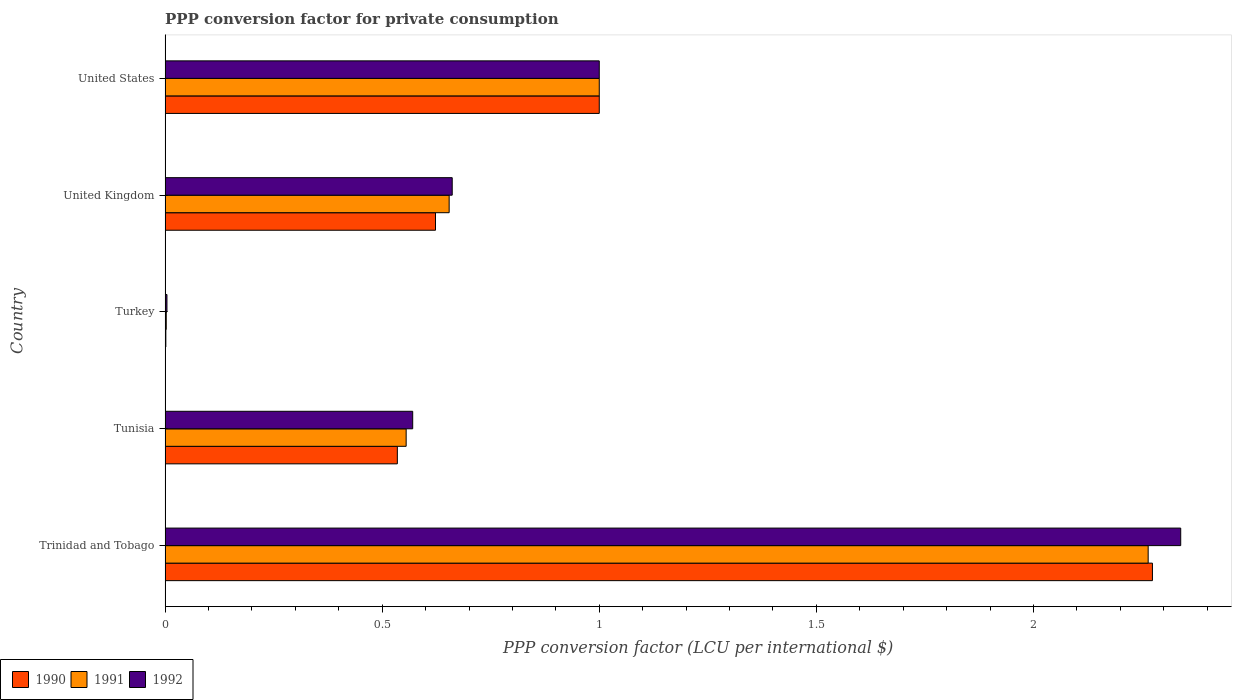How many groups of bars are there?
Make the answer very short. 5. Are the number of bars on each tick of the Y-axis equal?
Your response must be concise. Yes. How many bars are there on the 5th tick from the bottom?
Keep it short and to the point. 3. What is the PPP conversion factor for private consumption in 1991 in United Kingdom?
Provide a succinct answer. 0.65. Across all countries, what is the maximum PPP conversion factor for private consumption in 1992?
Provide a succinct answer. 2.34. Across all countries, what is the minimum PPP conversion factor for private consumption in 1990?
Your response must be concise. 0. In which country was the PPP conversion factor for private consumption in 1991 maximum?
Ensure brevity in your answer.  Trinidad and Tobago. In which country was the PPP conversion factor for private consumption in 1991 minimum?
Give a very brief answer. Turkey. What is the total PPP conversion factor for private consumption in 1992 in the graph?
Offer a very short reply. 4.58. What is the difference between the PPP conversion factor for private consumption in 1991 in Trinidad and Tobago and that in United States?
Make the answer very short. 1.26. What is the difference between the PPP conversion factor for private consumption in 1991 in United States and the PPP conversion factor for private consumption in 1992 in Trinidad and Tobago?
Your answer should be very brief. -1.34. What is the average PPP conversion factor for private consumption in 1991 per country?
Make the answer very short. 0.9. What is the difference between the PPP conversion factor for private consumption in 1992 and PPP conversion factor for private consumption in 1990 in Tunisia?
Ensure brevity in your answer.  0.04. In how many countries, is the PPP conversion factor for private consumption in 1991 greater than 0.5 LCU?
Offer a very short reply. 4. What is the ratio of the PPP conversion factor for private consumption in 1990 in Turkey to that in United States?
Make the answer very short. 0. Is the difference between the PPP conversion factor for private consumption in 1992 in Trinidad and Tobago and United States greater than the difference between the PPP conversion factor for private consumption in 1990 in Trinidad and Tobago and United States?
Ensure brevity in your answer.  Yes. What is the difference between the highest and the second highest PPP conversion factor for private consumption in 1991?
Give a very brief answer. 1.26. What is the difference between the highest and the lowest PPP conversion factor for private consumption in 1991?
Offer a terse response. 2.26. Is the sum of the PPP conversion factor for private consumption in 1992 in Turkey and United Kingdom greater than the maximum PPP conversion factor for private consumption in 1990 across all countries?
Make the answer very short. No. What does the 1st bar from the bottom in United States represents?
Offer a terse response. 1990. Is it the case that in every country, the sum of the PPP conversion factor for private consumption in 1990 and PPP conversion factor for private consumption in 1992 is greater than the PPP conversion factor for private consumption in 1991?
Your response must be concise. Yes. How many bars are there?
Provide a succinct answer. 15. Are the values on the major ticks of X-axis written in scientific E-notation?
Offer a terse response. No. Does the graph contain any zero values?
Your answer should be compact. No. Does the graph contain grids?
Provide a short and direct response. No. How many legend labels are there?
Your response must be concise. 3. How are the legend labels stacked?
Provide a succinct answer. Horizontal. What is the title of the graph?
Your answer should be compact. PPP conversion factor for private consumption. Does "1999" appear as one of the legend labels in the graph?
Give a very brief answer. No. What is the label or title of the X-axis?
Your answer should be compact. PPP conversion factor (LCU per international $). What is the PPP conversion factor (LCU per international $) of 1990 in Trinidad and Tobago?
Make the answer very short. 2.27. What is the PPP conversion factor (LCU per international $) in 1991 in Trinidad and Tobago?
Offer a terse response. 2.26. What is the PPP conversion factor (LCU per international $) of 1992 in Trinidad and Tobago?
Make the answer very short. 2.34. What is the PPP conversion factor (LCU per international $) in 1990 in Tunisia?
Ensure brevity in your answer.  0.53. What is the PPP conversion factor (LCU per international $) of 1991 in Tunisia?
Make the answer very short. 0.56. What is the PPP conversion factor (LCU per international $) in 1992 in Tunisia?
Offer a very short reply. 0.57. What is the PPP conversion factor (LCU per international $) in 1990 in Turkey?
Your answer should be compact. 0. What is the PPP conversion factor (LCU per international $) of 1991 in Turkey?
Your answer should be compact. 0. What is the PPP conversion factor (LCU per international $) in 1992 in Turkey?
Ensure brevity in your answer.  0. What is the PPP conversion factor (LCU per international $) in 1990 in United Kingdom?
Keep it short and to the point. 0.62. What is the PPP conversion factor (LCU per international $) of 1991 in United Kingdom?
Keep it short and to the point. 0.65. What is the PPP conversion factor (LCU per international $) in 1992 in United Kingdom?
Your answer should be very brief. 0.66. What is the PPP conversion factor (LCU per international $) in 1990 in United States?
Offer a very short reply. 1. What is the PPP conversion factor (LCU per international $) of 1991 in United States?
Provide a short and direct response. 1. What is the PPP conversion factor (LCU per international $) of 1992 in United States?
Your response must be concise. 1. Across all countries, what is the maximum PPP conversion factor (LCU per international $) of 1990?
Your answer should be very brief. 2.27. Across all countries, what is the maximum PPP conversion factor (LCU per international $) in 1991?
Your answer should be very brief. 2.26. Across all countries, what is the maximum PPP conversion factor (LCU per international $) in 1992?
Your response must be concise. 2.34. Across all countries, what is the minimum PPP conversion factor (LCU per international $) in 1990?
Offer a very short reply. 0. Across all countries, what is the minimum PPP conversion factor (LCU per international $) of 1991?
Provide a succinct answer. 0. Across all countries, what is the minimum PPP conversion factor (LCU per international $) of 1992?
Keep it short and to the point. 0. What is the total PPP conversion factor (LCU per international $) in 1990 in the graph?
Offer a very short reply. 4.43. What is the total PPP conversion factor (LCU per international $) in 1991 in the graph?
Make the answer very short. 4.48. What is the total PPP conversion factor (LCU per international $) of 1992 in the graph?
Your response must be concise. 4.58. What is the difference between the PPP conversion factor (LCU per international $) in 1990 in Trinidad and Tobago and that in Tunisia?
Give a very brief answer. 1.74. What is the difference between the PPP conversion factor (LCU per international $) of 1991 in Trinidad and Tobago and that in Tunisia?
Offer a terse response. 1.71. What is the difference between the PPP conversion factor (LCU per international $) of 1992 in Trinidad and Tobago and that in Tunisia?
Your answer should be very brief. 1.77. What is the difference between the PPP conversion factor (LCU per international $) in 1990 in Trinidad and Tobago and that in Turkey?
Your answer should be very brief. 2.27. What is the difference between the PPP conversion factor (LCU per international $) of 1991 in Trinidad and Tobago and that in Turkey?
Your answer should be compact. 2.26. What is the difference between the PPP conversion factor (LCU per international $) in 1992 in Trinidad and Tobago and that in Turkey?
Keep it short and to the point. 2.33. What is the difference between the PPP conversion factor (LCU per international $) of 1990 in Trinidad and Tobago and that in United Kingdom?
Make the answer very short. 1.65. What is the difference between the PPP conversion factor (LCU per international $) in 1991 in Trinidad and Tobago and that in United Kingdom?
Your response must be concise. 1.61. What is the difference between the PPP conversion factor (LCU per international $) in 1992 in Trinidad and Tobago and that in United Kingdom?
Your response must be concise. 1.68. What is the difference between the PPP conversion factor (LCU per international $) of 1990 in Trinidad and Tobago and that in United States?
Make the answer very short. 1.27. What is the difference between the PPP conversion factor (LCU per international $) in 1991 in Trinidad and Tobago and that in United States?
Give a very brief answer. 1.26. What is the difference between the PPP conversion factor (LCU per international $) in 1992 in Trinidad and Tobago and that in United States?
Offer a terse response. 1.34. What is the difference between the PPP conversion factor (LCU per international $) in 1990 in Tunisia and that in Turkey?
Your response must be concise. 0.53. What is the difference between the PPP conversion factor (LCU per international $) in 1991 in Tunisia and that in Turkey?
Ensure brevity in your answer.  0.55. What is the difference between the PPP conversion factor (LCU per international $) of 1992 in Tunisia and that in Turkey?
Provide a succinct answer. 0.57. What is the difference between the PPP conversion factor (LCU per international $) in 1990 in Tunisia and that in United Kingdom?
Your answer should be compact. -0.09. What is the difference between the PPP conversion factor (LCU per international $) of 1991 in Tunisia and that in United Kingdom?
Provide a short and direct response. -0.1. What is the difference between the PPP conversion factor (LCU per international $) of 1992 in Tunisia and that in United Kingdom?
Your answer should be compact. -0.09. What is the difference between the PPP conversion factor (LCU per international $) of 1990 in Tunisia and that in United States?
Offer a very short reply. -0.47. What is the difference between the PPP conversion factor (LCU per international $) in 1991 in Tunisia and that in United States?
Provide a succinct answer. -0.44. What is the difference between the PPP conversion factor (LCU per international $) in 1992 in Tunisia and that in United States?
Offer a very short reply. -0.43. What is the difference between the PPP conversion factor (LCU per international $) of 1990 in Turkey and that in United Kingdom?
Give a very brief answer. -0.62. What is the difference between the PPP conversion factor (LCU per international $) of 1991 in Turkey and that in United Kingdom?
Your response must be concise. -0.65. What is the difference between the PPP conversion factor (LCU per international $) in 1992 in Turkey and that in United Kingdom?
Your answer should be very brief. -0.66. What is the difference between the PPP conversion factor (LCU per international $) of 1990 in Turkey and that in United States?
Give a very brief answer. -1. What is the difference between the PPP conversion factor (LCU per international $) of 1991 in Turkey and that in United States?
Your answer should be compact. -1. What is the difference between the PPP conversion factor (LCU per international $) in 1992 in Turkey and that in United States?
Offer a terse response. -1. What is the difference between the PPP conversion factor (LCU per international $) in 1990 in United Kingdom and that in United States?
Your response must be concise. -0.38. What is the difference between the PPP conversion factor (LCU per international $) in 1991 in United Kingdom and that in United States?
Make the answer very short. -0.35. What is the difference between the PPP conversion factor (LCU per international $) of 1992 in United Kingdom and that in United States?
Offer a very short reply. -0.34. What is the difference between the PPP conversion factor (LCU per international $) in 1990 in Trinidad and Tobago and the PPP conversion factor (LCU per international $) in 1991 in Tunisia?
Give a very brief answer. 1.72. What is the difference between the PPP conversion factor (LCU per international $) of 1990 in Trinidad and Tobago and the PPP conversion factor (LCU per international $) of 1992 in Tunisia?
Your answer should be very brief. 1.7. What is the difference between the PPP conversion factor (LCU per international $) in 1991 in Trinidad and Tobago and the PPP conversion factor (LCU per international $) in 1992 in Tunisia?
Make the answer very short. 1.69. What is the difference between the PPP conversion factor (LCU per international $) in 1990 in Trinidad and Tobago and the PPP conversion factor (LCU per international $) in 1991 in Turkey?
Ensure brevity in your answer.  2.27. What is the difference between the PPP conversion factor (LCU per international $) in 1990 in Trinidad and Tobago and the PPP conversion factor (LCU per international $) in 1992 in Turkey?
Make the answer very short. 2.27. What is the difference between the PPP conversion factor (LCU per international $) in 1991 in Trinidad and Tobago and the PPP conversion factor (LCU per international $) in 1992 in Turkey?
Give a very brief answer. 2.26. What is the difference between the PPP conversion factor (LCU per international $) in 1990 in Trinidad and Tobago and the PPP conversion factor (LCU per international $) in 1991 in United Kingdom?
Provide a short and direct response. 1.62. What is the difference between the PPP conversion factor (LCU per international $) of 1990 in Trinidad and Tobago and the PPP conversion factor (LCU per international $) of 1992 in United Kingdom?
Your response must be concise. 1.61. What is the difference between the PPP conversion factor (LCU per international $) of 1991 in Trinidad and Tobago and the PPP conversion factor (LCU per international $) of 1992 in United Kingdom?
Your response must be concise. 1.6. What is the difference between the PPP conversion factor (LCU per international $) of 1990 in Trinidad and Tobago and the PPP conversion factor (LCU per international $) of 1991 in United States?
Your answer should be very brief. 1.27. What is the difference between the PPP conversion factor (LCU per international $) in 1990 in Trinidad and Tobago and the PPP conversion factor (LCU per international $) in 1992 in United States?
Ensure brevity in your answer.  1.27. What is the difference between the PPP conversion factor (LCU per international $) of 1991 in Trinidad and Tobago and the PPP conversion factor (LCU per international $) of 1992 in United States?
Offer a very short reply. 1.26. What is the difference between the PPP conversion factor (LCU per international $) of 1990 in Tunisia and the PPP conversion factor (LCU per international $) of 1991 in Turkey?
Provide a succinct answer. 0.53. What is the difference between the PPP conversion factor (LCU per international $) of 1990 in Tunisia and the PPP conversion factor (LCU per international $) of 1992 in Turkey?
Offer a terse response. 0.53. What is the difference between the PPP conversion factor (LCU per international $) of 1991 in Tunisia and the PPP conversion factor (LCU per international $) of 1992 in Turkey?
Ensure brevity in your answer.  0.55. What is the difference between the PPP conversion factor (LCU per international $) in 1990 in Tunisia and the PPP conversion factor (LCU per international $) in 1991 in United Kingdom?
Give a very brief answer. -0.12. What is the difference between the PPP conversion factor (LCU per international $) of 1990 in Tunisia and the PPP conversion factor (LCU per international $) of 1992 in United Kingdom?
Keep it short and to the point. -0.13. What is the difference between the PPP conversion factor (LCU per international $) of 1991 in Tunisia and the PPP conversion factor (LCU per international $) of 1992 in United Kingdom?
Provide a succinct answer. -0.11. What is the difference between the PPP conversion factor (LCU per international $) in 1990 in Tunisia and the PPP conversion factor (LCU per international $) in 1991 in United States?
Provide a short and direct response. -0.47. What is the difference between the PPP conversion factor (LCU per international $) in 1990 in Tunisia and the PPP conversion factor (LCU per international $) in 1992 in United States?
Your response must be concise. -0.47. What is the difference between the PPP conversion factor (LCU per international $) of 1991 in Tunisia and the PPP conversion factor (LCU per international $) of 1992 in United States?
Ensure brevity in your answer.  -0.44. What is the difference between the PPP conversion factor (LCU per international $) of 1990 in Turkey and the PPP conversion factor (LCU per international $) of 1991 in United Kingdom?
Your answer should be compact. -0.65. What is the difference between the PPP conversion factor (LCU per international $) in 1990 in Turkey and the PPP conversion factor (LCU per international $) in 1992 in United Kingdom?
Keep it short and to the point. -0.66. What is the difference between the PPP conversion factor (LCU per international $) in 1991 in Turkey and the PPP conversion factor (LCU per international $) in 1992 in United Kingdom?
Your answer should be very brief. -0.66. What is the difference between the PPP conversion factor (LCU per international $) in 1990 in Turkey and the PPP conversion factor (LCU per international $) in 1991 in United States?
Make the answer very short. -1. What is the difference between the PPP conversion factor (LCU per international $) in 1990 in Turkey and the PPP conversion factor (LCU per international $) in 1992 in United States?
Your answer should be compact. -1. What is the difference between the PPP conversion factor (LCU per international $) in 1991 in Turkey and the PPP conversion factor (LCU per international $) in 1992 in United States?
Provide a succinct answer. -1. What is the difference between the PPP conversion factor (LCU per international $) in 1990 in United Kingdom and the PPP conversion factor (LCU per international $) in 1991 in United States?
Ensure brevity in your answer.  -0.38. What is the difference between the PPP conversion factor (LCU per international $) in 1990 in United Kingdom and the PPP conversion factor (LCU per international $) in 1992 in United States?
Keep it short and to the point. -0.38. What is the difference between the PPP conversion factor (LCU per international $) of 1991 in United Kingdom and the PPP conversion factor (LCU per international $) of 1992 in United States?
Keep it short and to the point. -0.35. What is the average PPP conversion factor (LCU per international $) of 1990 per country?
Your answer should be very brief. 0.89. What is the average PPP conversion factor (LCU per international $) in 1991 per country?
Keep it short and to the point. 0.9. What is the average PPP conversion factor (LCU per international $) in 1992 per country?
Your answer should be very brief. 0.92. What is the difference between the PPP conversion factor (LCU per international $) of 1990 and PPP conversion factor (LCU per international $) of 1991 in Trinidad and Tobago?
Make the answer very short. 0.01. What is the difference between the PPP conversion factor (LCU per international $) of 1990 and PPP conversion factor (LCU per international $) of 1992 in Trinidad and Tobago?
Your answer should be very brief. -0.07. What is the difference between the PPP conversion factor (LCU per international $) of 1991 and PPP conversion factor (LCU per international $) of 1992 in Trinidad and Tobago?
Give a very brief answer. -0.07. What is the difference between the PPP conversion factor (LCU per international $) in 1990 and PPP conversion factor (LCU per international $) in 1991 in Tunisia?
Provide a short and direct response. -0.02. What is the difference between the PPP conversion factor (LCU per international $) of 1990 and PPP conversion factor (LCU per international $) of 1992 in Tunisia?
Your answer should be compact. -0.04. What is the difference between the PPP conversion factor (LCU per international $) in 1991 and PPP conversion factor (LCU per international $) in 1992 in Tunisia?
Your answer should be very brief. -0.02. What is the difference between the PPP conversion factor (LCU per international $) of 1990 and PPP conversion factor (LCU per international $) of 1991 in Turkey?
Ensure brevity in your answer.  -0. What is the difference between the PPP conversion factor (LCU per international $) of 1990 and PPP conversion factor (LCU per international $) of 1992 in Turkey?
Ensure brevity in your answer.  -0. What is the difference between the PPP conversion factor (LCU per international $) in 1991 and PPP conversion factor (LCU per international $) in 1992 in Turkey?
Your answer should be very brief. -0. What is the difference between the PPP conversion factor (LCU per international $) of 1990 and PPP conversion factor (LCU per international $) of 1991 in United Kingdom?
Your answer should be very brief. -0.03. What is the difference between the PPP conversion factor (LCU per international $) in 1990 and PPP conversion factor (LCU per international $) in 1992 in United Kingdom?
Make the answer very short. -0.04. What is the difference between the PPP conversion factor (LCU per international $) of 1991 and PPP conversion factor (LCU per international $) of 1992 in United Kingdom?
Provide a succinct answer. -0.01. What is the ratio of the PPP conversion factor (LCU per international $) in 1990 in Trinidad and Tobago to that in Tunisia?
Make the answer very short. 4.25. What is the ratio of the PPP conversion factor (LCU per international $) in 1991 in Trinidad and Tobago to that in Tunisia?
Provide a succinct answer. 4.08. What is the ratio of the PPP conversion factor (LCU per international $) of 1992 in Trinidad and Tobago to that in Tunisia?
Your answer should be very brief. 4.1. What is the ratio of the PPP conversion factor (LCU per international $) in 1990 in Trinidad and Tobago to that in Turkey?
Keep it short and to the point. 1329.9. What is the ratio of the PPP conversion factor (LCU per international $) in 1991 in Trinidad and Tobago to that in Turkey?
Keep it short and to the point. 850.91. What is the ratio of the PPP conversion factor (LCU per international $) in 1992 in Trinidad and Tobago to that in Turkey?
Provide a succinct answer. 545.15. What is the ratio of the PPP conversion factor (LCU per international $) in 1990 in Trinidad and Tobago to that in United Kingdom?
Offer a terse response. 3.65. What is the ratio of the PPP conversion factor (LCU per international $) in 1991 in Trinidad and Tobago to that in United Kingdom?
Your answer should be very brief. 3.46. What is the ratio of the PPP conversion factor (LCU per international $) of 1992 in Trinidad and Tobago to that in United Kingdom?
Provide a succinct answer. 3.54. What is the ratio of the PPP conversion factor (LCU per international $) of 1990 in Trinidad and Tobago to that in United States?
Provide a succinct answer. 2.27. What is the ratio of the PPP conversion factor (LCU per international $) in 1991 in Trinidad and Tobago to that in United States?
Provide a succinct answer. 2.26. What is the ratio of the PPP conversion factor (LCU per international $) in 1992 in Trinidad and Tobago to that in United States?
Your answer should be compact. 2.34. What is the ratio of the PPP conversion factor (LCU per international $) in 1990 in Tunisia to that in Turkey?
Provide a succinct answer. 312.81. What is the ratio of the PPP conversion factor (LCU per international $) of 1991 in Tunisia to that in Turkey?
Make the answer very short. 208.65. What is the ratio of the PPP conversion factor (LCU per international $) in 1992 in Tunisia to that in Turkey?
Ensure brevity in your answer.  132.9. What is the ratio of the PPP conversion factor (LCU per international $) in 1990 in Tunisia to that in United Kingdom?
Offer a very short reply. 0.86. What is the ratio of the PPP conversion factor (LCU per international $) in 1991 in Tunisia to that in United Kingdom?
Your answer should be very brief. 0.85. What is the ratio of the PPP conversion factor (LCU per international $) of 1992 in Tunisia to that in United Kingdom?
Give a very brief answer. 0.86. What is the ratio of the PPP conversion factor (LCU per international $) of 1990 in Tunisia to that in United States?
Offer a terse response. 0.53. What is the ratio of the PPP conversion factor (LCU per international $) of 1991 in Tunisia to that in United States?
Your answer should be very brief. 0.56. What is the ratio of the PPP conversion factor (LCU per international $) in 1992 in Tunisia to that in United States?
Make the answer very short. 0.57. What is the ratio of the PPP conversion factor (LCU per international $) of 1990 in Turkey to that in United Kingdom?
Provide a short and direct response. 0. What is the ratio of the PPP conversion factor (LCU per international $) of 1991 in Turkey to that in United Kingdom?
Ensure brevity in your answer.  0. What is the ratio of the PPP conversion factor (LCU per international $) of 1992 in Turkey to that in United Kingdom?
Provide a short and direct response. 0.01. What is the ratio of the PPP conversion factor (LCU per international $) of 1990 in Turkey to that in United States?
Offer a very short reply. 0. What is the ratio of the PPP conversion factor (LCU per international $) in 1991 in Turkey to that in United States?
Your answer should be very brief. 0. What is the ratio of the PPP conversion factor (LCU per international $) in 1992 in Turkey to that in United States?
Provide a succinct answer. 0. What is the ratio of the PPP conversion factor (LCU per international $) in 1990 in United Kingdom to that in United States?
Give a very brief answer. 0.62. What is the ratio of the PPP conversion factor (LCU per international $) of 1991 in United Kingdom to that in United States?
Offer a terse response. 0.65. What is the ratio of the PPP conversion factor (LCU per international $) of 1992 in United Kingdom to that in United States?
Your answer should be very brief. 0.66. What is the difference between the highest and the second highest PPP conversion factor (LCU per international $) in 1990?
Provide a short and direct response. 1.27. What is the difference between the highest and the second highest PPP conversion factor (LCU per international $) in 1991?
Offer a terse response. 1.26. What is the difference between the highest and the second highest PPP conversion factor (LCU per international $) in 1992?
Provide a succinct answer. 1.34. What is the difference between the highest and the lowest PPP conversion factor (LCU per international $) of 1990?
Provide a succinct answer. 2.27. What is the difference between the highest and the lowest PPP conversion factor (LCU per international $) of 1991?
Ensure brevity in your answer.  2.26. What is the difference between the highest and the lowest PPP conversion factor (LCU per international $) of 1992?
Give a very brief answer. 2.33. 